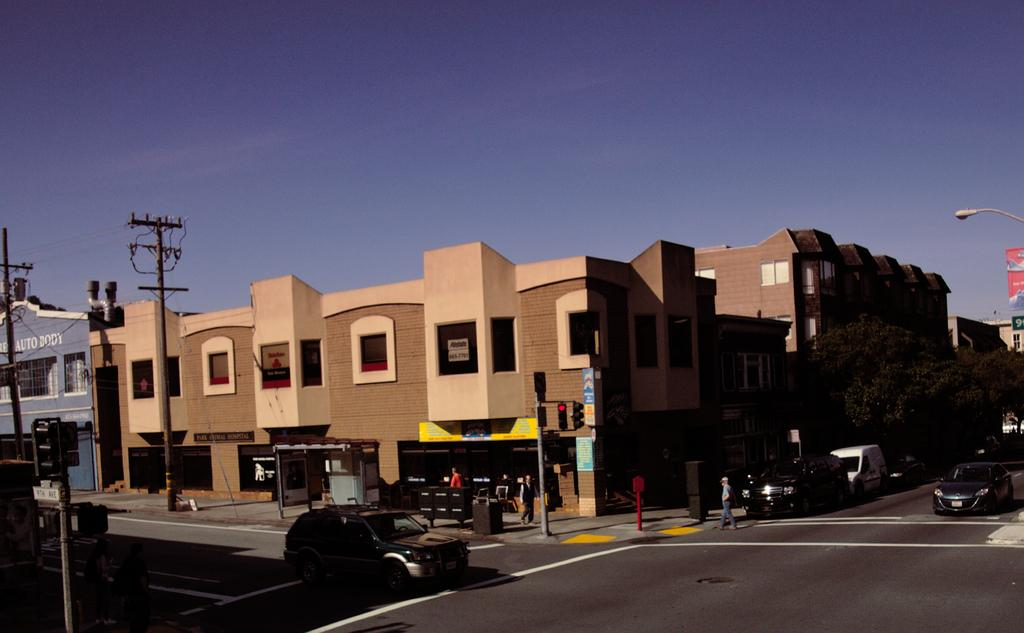What is happening on the road in the image? There are vehicles on a road in the image. What are people doing in the image? People are walking on a footpath in the image. What structures can be seen in the image? There are electrical poles in the image. What can be seen in the distance in the image? There are buildings in the background of the image, and the sky is visible in the background as well. How many pages are visible in the image? There are no pages present in the image. What type of detail can be seen on the vehicles in the image? The provided facts do not mention any specific details on the vehicles, so we cannot answer this question based on the given information. 